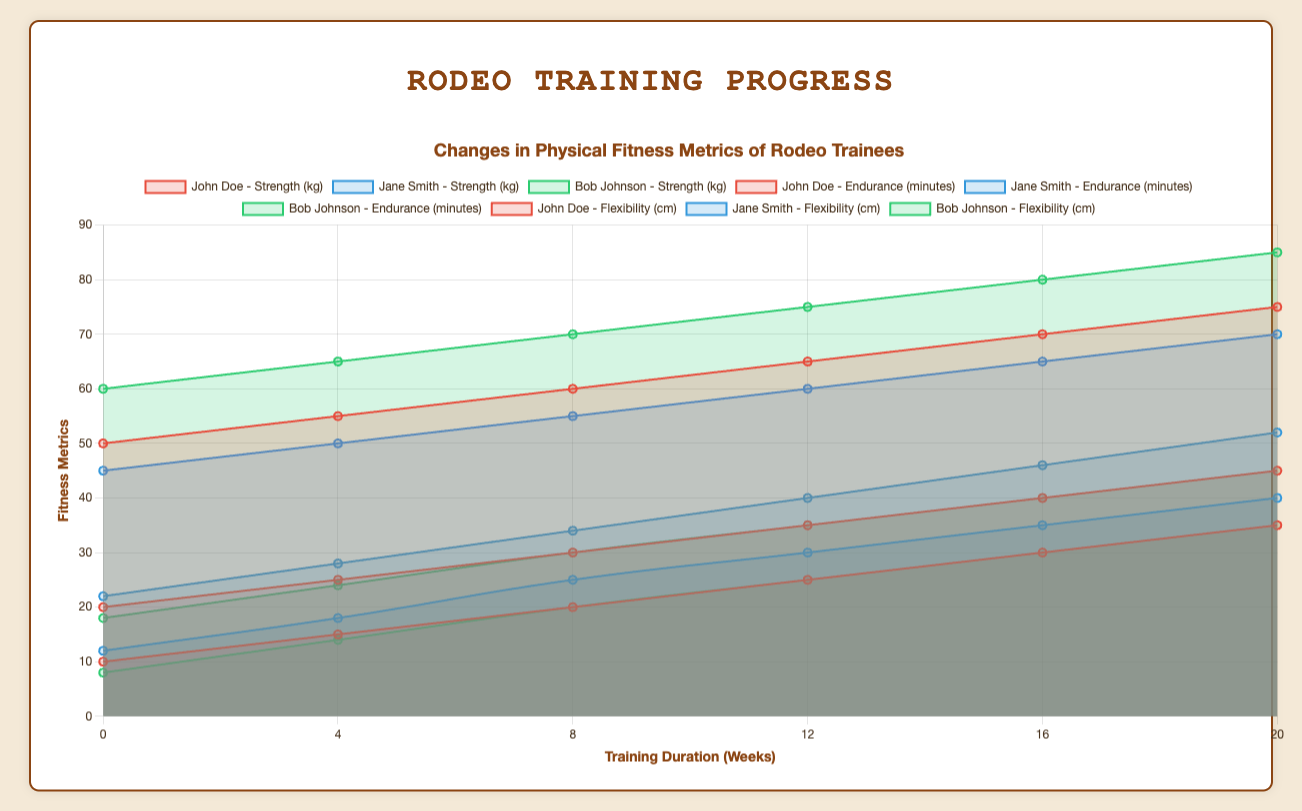Which trainee improved the most in Strength over the training period? Check the initial and final Strength values for each trainee: John Doe (50 to 75 kg), Jane Smith (45 to 70 kg), and Bob Johnson (60 to 85 kg). The change is 25 kg for each trainee, so all trainees improved equally.
Answer: All trainees improved equally Whose Endurance increased more rapidly between weeks 8 and 12? Compare the changes in Endurance from week 8 to week 12 for John Doe (20 to 25 minutes), Jane Smith (25 to 30 minutes), and Bob Johnson (20 to 25 minutes). The increase is the same for all trainees (5 minutes).
Answer: All trainees increased equally Between which weeks did Jane Smith show the greatest increase in Flexibility? Calculate the change in Flexibility for Jane Smith between each pair of weeks: 0 to 4 (22 to 28 cm, +6 cm), 4 to 8 (28 to 34 cm, +6 cm), 8 to 12 (34 to 40 cm, +6 cm), 12 to 16 (40 to 46 cm, +6 cm), and 16 to 20 (46 to 52 cm, +6 cm). The increase is the same between each interval.
Answer: The same over each interval (6 cm) At week 12, who had the highest combined metric values for Strength, Endurance, and Flexibility? Check the values at week 12: John Doe (Strength 65 kg, Endurance 25 minutes, Flexibility 35 cm), Jane Smith (Strength 60 kg, Endurance 30 minutes, Flexibility 40 cm), and Bob Johnson (Strength 75 kg, Endurance 25 minutes, Flexibility 35 cm). Combine the values: John Doe (125), Jane Smith (130), Bob Johnson (135).
Answer: Bob Johnson Between weeks 0 and 20, which metric for Bob Johnson showed the highest absolute increase? Calculate the total increase for each metric: Strength (60 to 85 kg, +25 kg), Endurance (8 to 35 minutes, +27 minutes), Flexibility (18 to 45 cm, +27 cm). Endurance and Flexibility had the highest increase of 27.
Answer: Endurance and Flexibility By week 16, who showed the least improvement in Flexibility? Compare the initial and week 16 values for Flexibility: John Doe (20 to 40 cm, +20 cm), Jane Smith (22 to 46 cm, +24 cm), Bob Johnson (18 to 40 cm, +22 cm). John Doe showed the least improvement.
Answer: John Doe For which trainee did Strength and Endurance improved at a uniform rate? Check the increase per interval for Strength and Endurance for each trainee. John Doe and Bob Johnson show consistent increments of 5 kg and 5 minutes,  respectively, every 4 weeks.
Answer: John Doe and Bob Johnson On average, how much did Jane Smith's Strength improve per month? Jane Smith's Strength increased from 45 kg to 70 kg over 20 weeks. Convert weeks to months (20 weeks / 4.33 weeks per month) = ~4.62 months. The total increase is 25 kg, so the average improvement per month is 25 kg / 4.62 months = ~5.41 kg/month.
Answer: 5.41 kg/month What's the average improvement in Endurance for all trainees over the training duration? Calculate the total increase in Endurance for each trainee (John Doe: 25 minutes, Jane Smith: 28 minutes, Bob Johnson: 27 minutes). Find the average: (25 + 28 + 27) / 3 = 26.67 minutes.
Answer: 26.67 minutes 